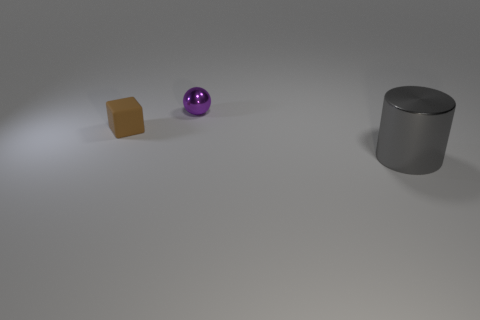Is there anything else that is the same color as the big cylinder?
Provide a succinct answer. No. Do the brown block and the purple metal ball have the same size?
Provide a succinct answer. Yes. What is the size of the thing that is both on the left side of the gray shiny object and right of the small brown matte cube?
Offer a terse response. Small. How many objects have the same material as the tiny purple sphere?
Offer a very short reply. 1. What color is the small cube?
Your answer should be very brief. Brown. There is a thing that is in front of the matte thing; does it have the same shape as the tiny brown matte thing?
Ensure brevity in your answer.  No. What number of things are shiny objects in front of the purple sphere or small purple rubber objects?
Your answer should be very brief. 1. Are there any big things that have the same shape as the tiny brown object?
Keep it short and to the point. No. What shape is the shiny thing that is the same size as the brown rubber block?
Provide a short and direct response. Sphere. There is a thing that is to the right of the purple object that is behind the small thing in front of the tiny purple shiny ball; what is its shape?
Your answer should be compact. Cylinder. 